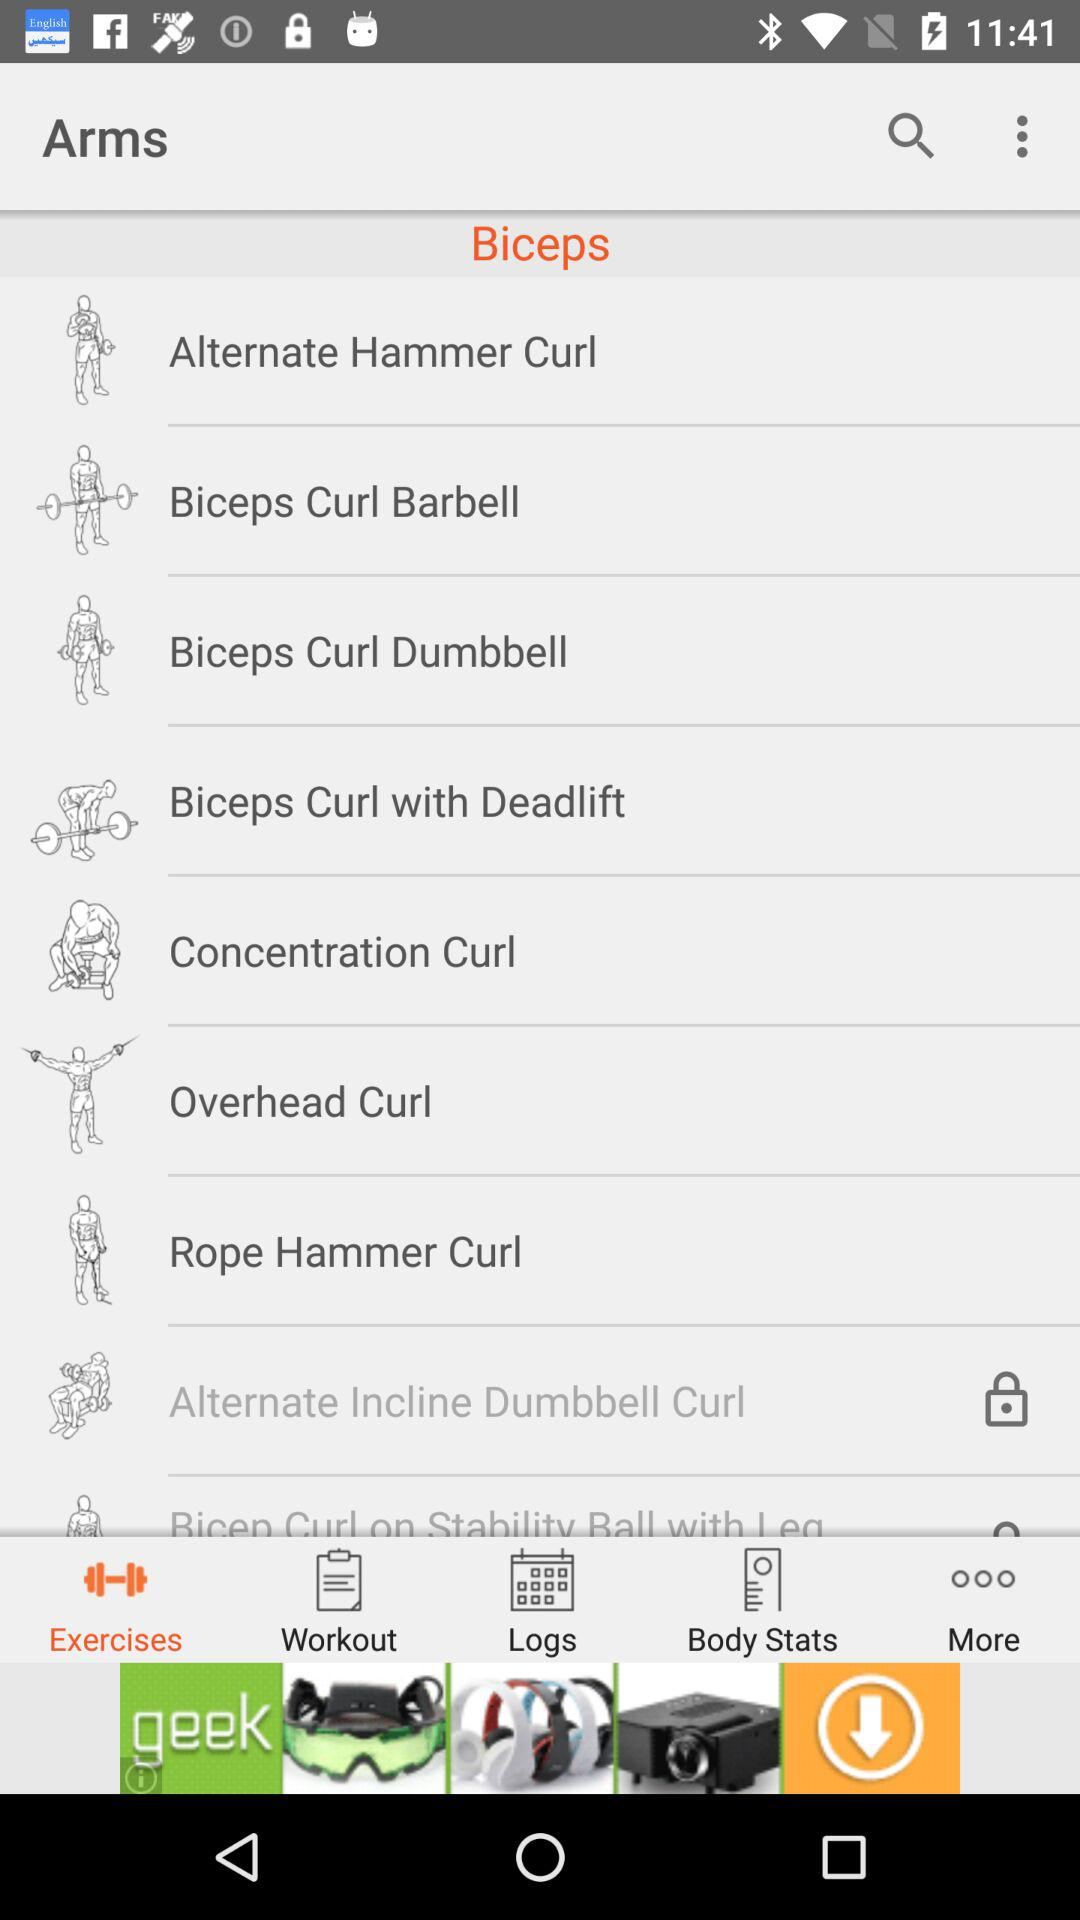Which tab is selected? The selected tab is "Exercises". 